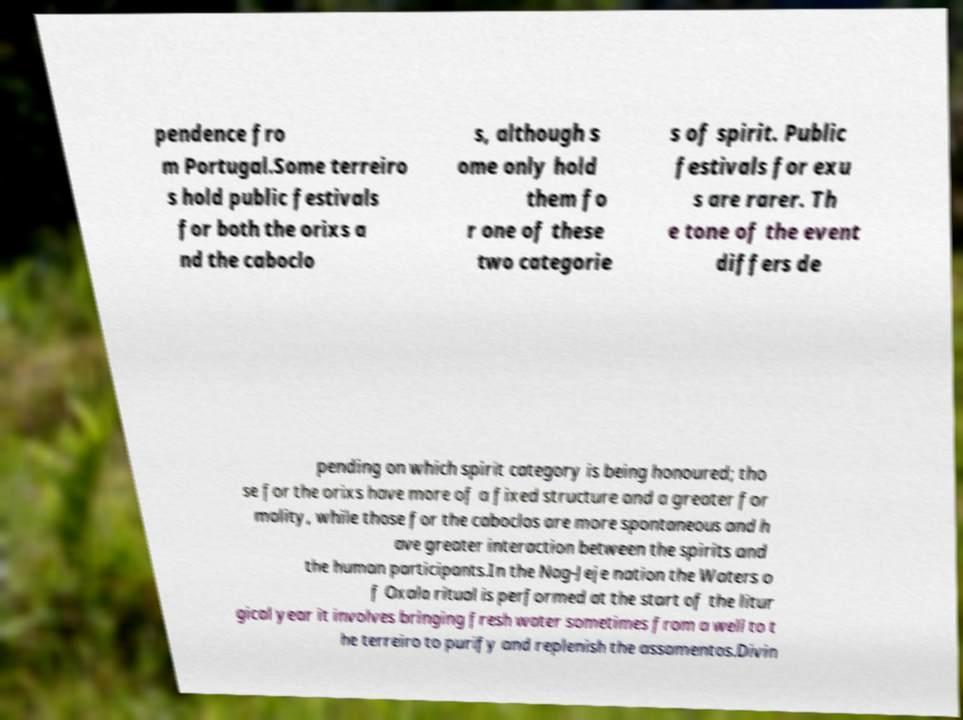For documentation purposes, I need the text within this image transcribed. Could you provide that? pendence fro m Portugal.Some terreiro s hold public festivals for both the orixs a nd the caboclo s, although s ome only hold them fo r one of these two categorie s of spirit. Public festivals for exu s are rarer. Th e tone of the event differs de pending on which spirit category is being honoured; tho se for the orixs have more of a fixed structure and a greater for mality, while those for the caboclos are more spontaneous and h ave greater interaction between the spirits and the human participants.In the Nag-Jeje nation the Waters o f Oxala ritual is performed at the start of the litur gical year it involves bringing fresh water sometimes from a well to t he terreiro to purify and replenish the assamentos.Divin 